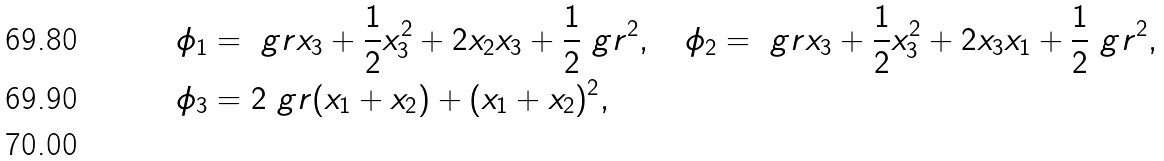<formula> <loc_0><loc_0><loc_500><loc_500>\phi _ { 1 } & = \ g r x _ { 3 } + \frac { 1 } { 2 } x _ { 3 } ^ { 2 } + 2 x _ { 2 } x _ { 3 } + \frac { 1 } { 2 } \ g r ^ { 2 } , \quad \phi _ { 2 } = \ g r x _ { 3 } + \frac { 1 } { 2 } x _ { 3 } ^ { 2 } + 2 x _ { 3 } x _ { 1 } + \frac { 1 } { 2 } \ g r ^ { 2 } , \\ \phi _ { 3 } & = 2 \ g r ( x _ { 1 } + x _ { 2 } ) + ( x _ { 1 } + x _ { 2 } ) ^ { 2 } , \\</formula> 